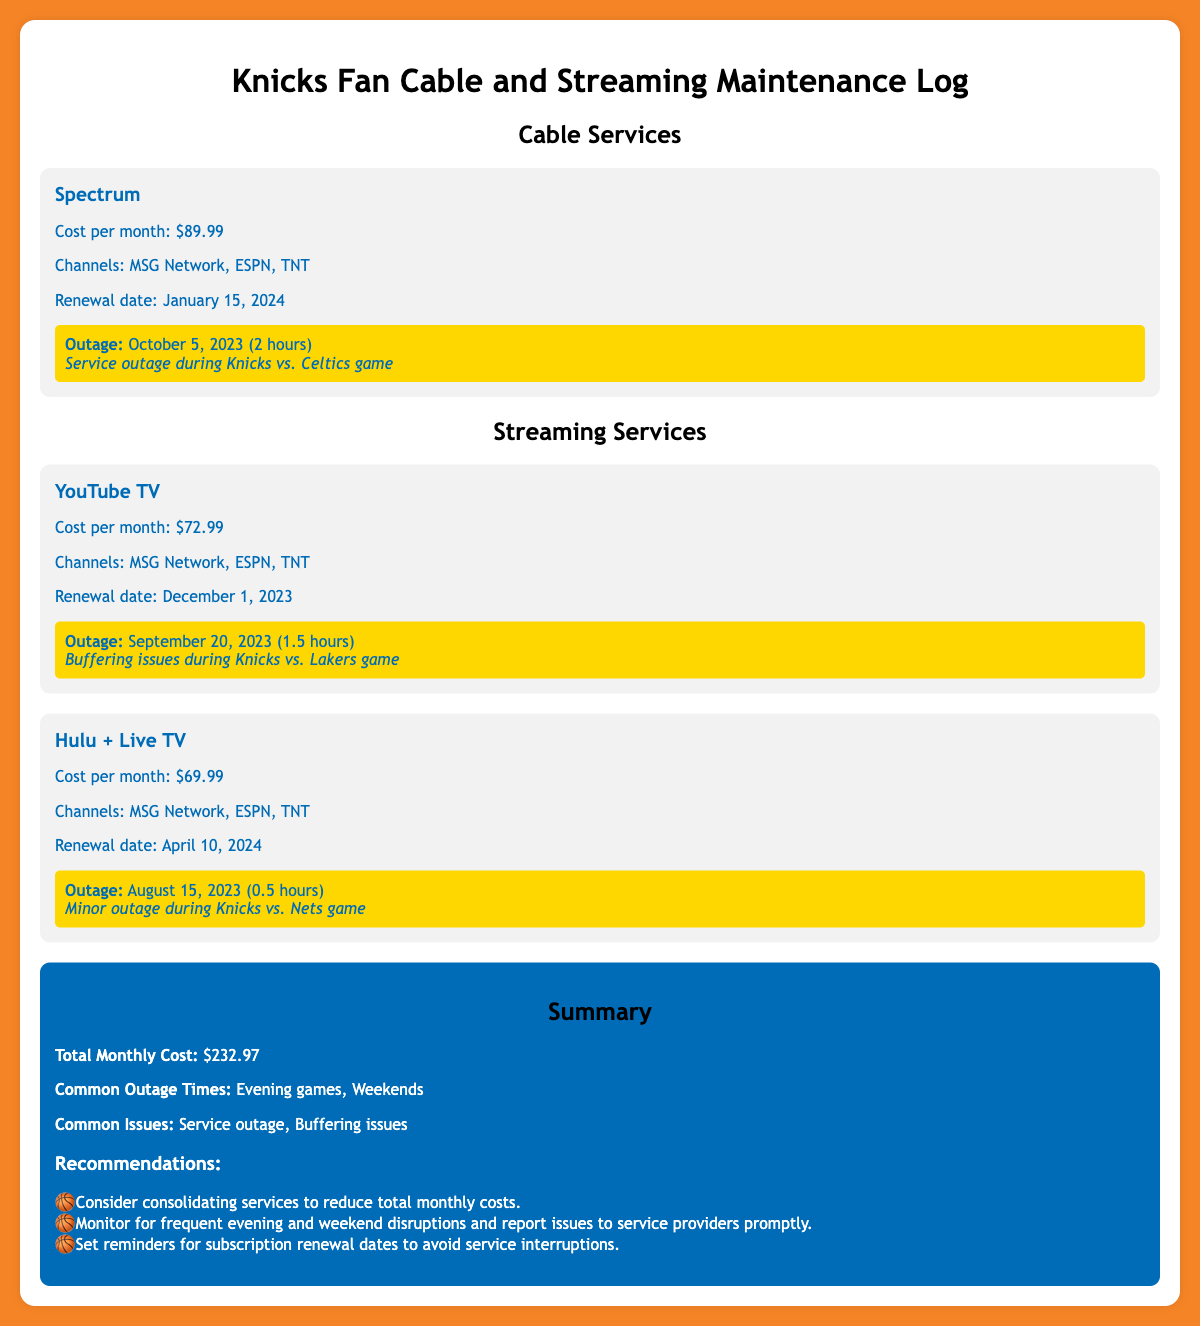What is the cost per month for Spectrum? The cost per month for Spectrum is mentioned in the document, which is $89.99.
Answer: $89.99 When is the renewal date for YouTube TV? The renewal date for YouTube TV is specifically stated in the document as December 1, 2023.
Answer: December 1, 2023 How long was the outage during the Knicks vs. Celtics game? The document specifies that the outage during the Knicks vs. Celtics game lasted for 2 hours.
Answer: 2 hours Which streaming service has the lowest monthly cost? The document lists the monthly costs, and Hulu + Live TV has the lowest cost at $69.99.
Answer: $69.99 What are the common outage times mentioned in the summary? The summary section notes that common outage times include evening games and weekends, highlighting when disruptions typically occur.
Answer: Evening games, Weekends How many services are mentioned in total? The document details three services, counting both cable and streaming services available for Knicks games.
Answer: Three What is the total monthly cost for all services? The total monthly cost is calculated in the summary section, which sums up to $232.97.
Answer: $232.97 What is a recommended action to avoid service interruptions? The recommendations section advises setting reminders for subscription renewal dates to avoid interruptions in service.
Answer: Set reminders for subscription renewal dates What major issue was noted during the Knicks vs. Lakers game? The outage description states there were buffering issues during the Knicks vs. Lakers game, indicating a specific type of problem encountered.
Answer: Buffering issues 